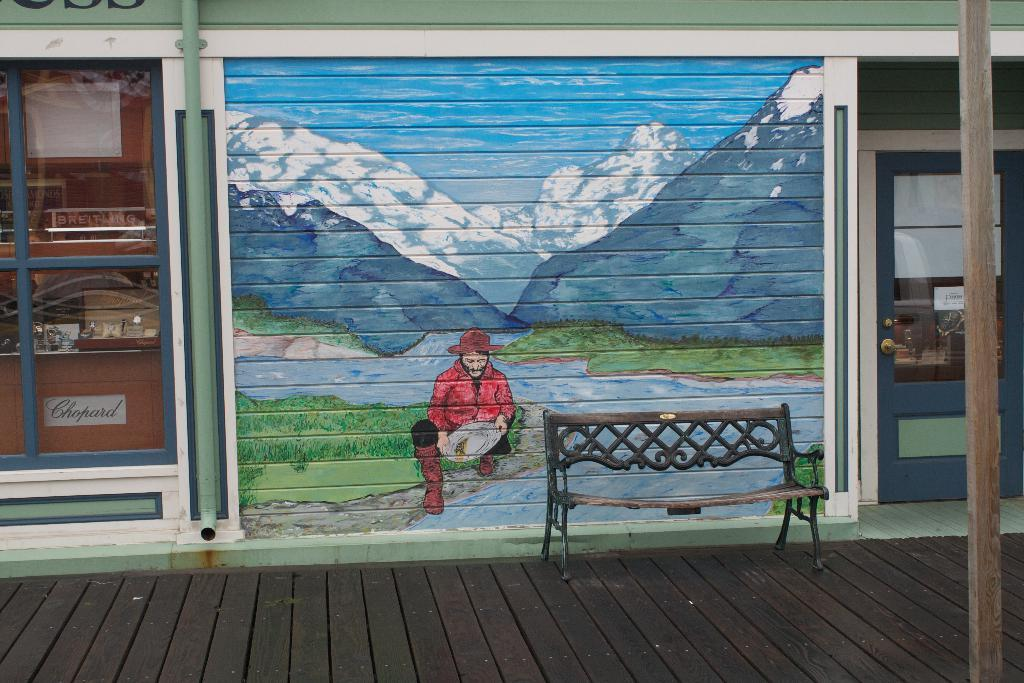What is located in the foreground of the image? There is a bench in the foreground of the image. Where is the bench positioned? The bench is on the floor. What can be seen in the background of the image? There is a shop, a wall, and a wall painting in the background of the image. Can you describe the time of day when the image was likely taken? The image was likely taken during the day, as there is sufficient light to see the details clearly. What type of air is being used to cool the shop in the image? There is no information about air conditioning or cooling in the image, so it cannot be determined what type of air is being used. 